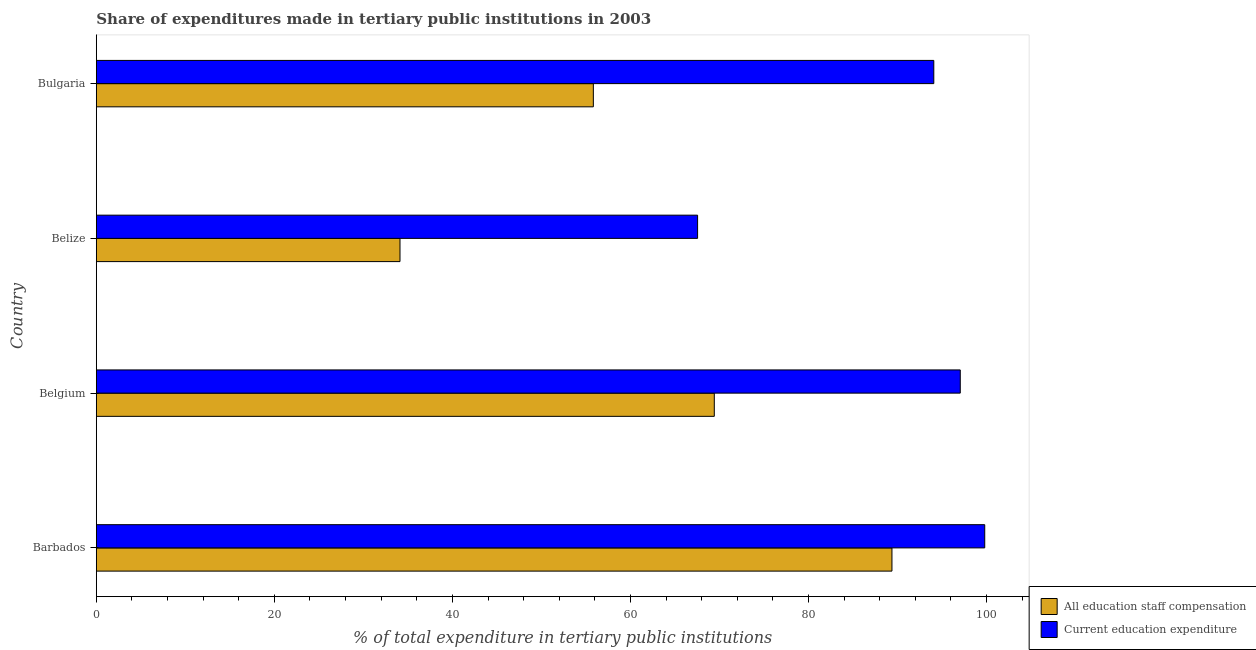How many different coloured bars are there?
Your answer should be compact. 2. How many groups of bars are there?
Make the answer very short. 4. How many bars are there on the 4th tick from the bottom?
Ensure brevity in your answer.  2. What is the label of the 1st group of bars from the top?
Offer a very short reply. Bulgaria. In how many cases, is the number of bars for a given country not equal to the number of legend labels?
Offer a very short reply. 0. What is the expenditure in education in Bulgaria?
Offer a terse response. 94.08. Across all countries, what is the maximum expenditure in staff compensation?
Provide a short and direct response. 89.38. Across all countries, what is the minimum expenditure in staff compensation?
Offer a very short reply. 34.11. In which country was the expenditure in staff compensation maximum?
Provide a succinct answer. Barbados. In which country was the expenditure in education minimum?
Offer a terse response. Belize. What is the total expenditure in staff compensation in the graph?
Provide a short and direct response. 248.76. What is the difference between the expenditure in education in Barbados and that in Bulgaria?
Your response must be concise. 5.72. What is the difference between the expenditure in education in Belgium and the expenditure in staff compensation in Barbados?
Offer a very short reply. 7.67. What is the average expenditure in staff compensation per country?
Ensure brevity in your answer.  62.19. What is the difference between the expenditure in staff compensation and expenditure in education in Barbados?
Provide a succinct answer. -10.42. What is the ratio of the expenditure in education in Barbados to that in Bulgaria?
Make the answer very short. 1.06. Is the difference between the expenditure in staff compensation in Belize and Bulgaria greater than the difference between the expenditure in education in Belize and Bulgaria?
Your response must be concise. Yes. What is the difference between the highest and the second highest expenditure in staff compensation?
Your answer should be compact. 19.96. What is the difference between the highest and the lowest expenditure in staff compensation?
Your response must be concise. 55.27. In how many countries, is the expenditure in education greater than the average expenditure in education taken over all countries?
Provide a short and direct response. 3. What does the 1st bar from the top in Belgium represents?
Your response must be concise. Current education expenditure. What does the 1st bar from the bottom in Belize represents?
Ensure brevity in your answer.  All education staff compensation. How are the legend labels stacked?
Make the answer very short. Vertical. What is the title of the graph?
Make the answer very short. Share of expenditures made in tertiary public institutions in 2003. What is the label or title of the X-axis?
Ensure brevity in your answer.  % of total expenditure in tertiary public institutions. What is the % of total expenditure in tertiary public institutions in All education staff compensation in Barbados?
Make the answer very short. 89.38. What is the % of total expenditure in tertiary public institutions of Current education expenditure in Barbados?
Give a very brief answer. 99.81. What is the % of total expenditure in tertiary public institutions in All education staff compensation in Belgium?
Your answer should be very brief. 69.43. What is the % of total expenditure in tertiary public institutions in Current education expenditure in Belgium?
Make the answer very short. 97.06. What is the % of total expenditure in tertiary public institutions in All education staff compensation in Belize?
Your answer should be compact. 34.11. What is the % of total expenditure in tertiary public institutions of Current education expenditure in Belize?
Your answer should be compact. 67.55. What is the % of total expenditure in tertiary public institutions in All education staff compensation in Bulgaria?
Keep it short and to the point. 55.84. What is the % of total expenditure in tertiary public institutions of Current education expenditure in Bulgaria?
Give a very brief answer. 94.08. Across all countries, what is the maximum % of total expenditure in tertiary public institutions of All education staff compensation?
Make the answer very short. 89.38. Across all countries, what is the maximum % of total expenditure in tertiary public institutions of Current education expenditure?
Ensure brevity in your answer.  99.81. Across all countries, what is the minimum % of total expenditure in tertiary public institutions of All education staff compensation?
Provide a short and direct response. 34.11. Across all countries, what is the minimum % of total expenditure in tertiary public institutions of Current education expenditure?
Provide a succinct answer. 67.55. What is the total % of total expenditure in tertiary public institutions in All education staff compensation in the graph?
Provide a succinct answer. 248.76. What is the total % of total expenditure in tertiary public institutions of Current education expenditure in the graph?
Provide a short and direct response. 358.5. What is the difference between the % of total expenditure in tertiary public institutions of All education staff compensation in Barbados and that in Belgium?
Keep it short and to the point. 19.96. What is the difference between the % of total expenditure in tertiary public institutions in Current education expenditure in Barbados and that in Belgium?
Ensure brevity in your answer.  2.75. What is the difference between the % of total expenditure in tertiary public institutions of All education staff compensation in Barbados and that in Belize?
Give a very brief answer. 55.27. What is the difference between the % of total expenditure in tertiary public institutions in Current education expenditure in Barbados and that in Belize?
Your response must be concise. 32.26. What is the difference between the % of total expenditure in tertiary public institutions in All education staff compensation in Barbados and that in Bulgaria?
Offer a very short reply. 33.55. What is the difference between the % of total expenditure in tertiary public institutions in Current education expenditure in Barbados and that in Bulgaria?
Make the answer very short. 5.72. What is the difference between the % of total expenditure in tertiary public institutions of All education staff compensation in Belgium and that in Belize?
Give a very brief answer. 35.31. What is the difference between the % of total expenditure in tertiary public institutions in Current education expenditure in Belgium and that in Belize?
Provide a succinct answer. 29.51. What is the difference between the % of total expenditure in tertiary public institutions of All education staff compensation in Belgium and that in Bulgaria?
Keep it short and to the point. 13.59. What is the difference between the % of total expenditure in tertiary public institutions in Current education expenditure in Belgium and that in Bulgaria?
Offer a terse response. 2.97. What is the difference between the % of total expenditure in tertiary public institutions in All education staff compensation in Belize and that in Bulgaria?
Provide a short and direct response. -21.72. What is the difference between the % of total expenditure in tertiary public institutions of Current education expenditure in Belize and that in Bulgaria?
Your response must be concise. -26.54. What is the difference between the % of total expenditure in tertiary public institutions of All education staff compensation in Barbados and the % of total expenditure in tertiary public institutions of Current education expenditure in Belgium?
Give a very brief answer. -7.67. What is the difference between the % of total expenditure in tertiary public institutions in All education staff compensation in Barbados and the % of total expenditure in tertiary public institutions in Current education expenditure in Belize?
Provide a succinct answer. 21.84. What is the difference between the % of total expenditure in tertiary public institutions in All education staff compensation in Barbados and the % of total expenditure in tertiary public institutions in Current education expenditure in Bulgaria?
Your answer should be compact. -4.7. What is the difference between the % of total expenditure in tertiary public institutions in All education staff compensation in Belgium and the % of total expenditure in tertiary public institutions in Current education expenditure in Belize?
Provide a succinct answer. 1.88. What is the difference between the % of total expenditure in tertiary public institutions of All education staff compensation in Belgium and the % of total expenditure in tertiary public institutions of Current education expenditure in Bulgaria?
Your answer should be compact. -24.66. What is the difference between the % of total expenditure in tertiary public institutions in All education staff compensation in Belize and the % of total expenditure in tertiary public institutions in Current education expenditure in Bulgaria?
Provide a succinct answer. -59.97. What is the average % of total expenditure in tertiary public institutions of All education staff compensation per country?
Your response must be concise. 62.19. What is the average % of total expenditure in tertiary public institutions in Current education expenditure per country?
Give a very brief answer. 89.62. What is the difference between the % of total expenditure in tertiary public institutions of All education staff compensation and % of total expenditure in tertiary public institutions of Current education expenditure in Barbados?
Your answer should be compact. -10.42. What is the difference between the % of total expenditure in tertiary public institutions of All education staff compensation and % of total expenditure in tertiary public institutions of Current education expenditure in Belgium?
Your answer should be compact. -27.63. What is the difference between the % of total expenditure in tertiary public institutions in All education staff compensation and % of total expenditure in tertiary public institutions in Current education expenditure in Belize?
Your answer should be compact. -33.43. What is the difference between the % of total expenditure in tertiary public institutions in All education staff compensation and % of total expenditure in tertiary public institutions in Current education expenditure in Bulgaria?
Keep it short and to the point. -38.25. What is the ratio of the % of total expenditure in tertiary public institutions of All education staff compensation in Barbados to that in Belgium?
Offer a terse response. 1.29. What is the ratio of the % of total expenditure in tertiary public institutions in Current education expenditure in Barbados to that in Belgium?
Your response must be concise. 1.03. What is the ratio of the % of total expenditure in tertiary public institutions in All education staff compensation in Barbados to that in Belize?
Your response must be concise. 2.62. What is the ratio of the % of total expenditure in tertiary public institutions in Current education expenditure in Barbados to that in Belize?
Ensure brevity in your answer.  1.48. What is the ratio of the % of total expenditure in tertiary public institutions in All education staff compensation in Barbados to that in Bulgaria?
Your response must be concise. 1.6. What is the ratio of the % of total expenditure in tertiary public institutions of Current education expenditure in Barbados to that in Bulgaria?
Your answer should be compact. 1.06. What is the ratio of the % of total expenditure in tertiary public institutions in All education staff compensation in Belgium to that in Belize?
Make the answer very short. 2.04. What is the ratio of the % of total expenditure in tertiary public institutions of Current education expenditure in Belgium to that in Belize?
Give a very brief answer. 1.44. What is the ratio of the % of total expenditure in tertiary public institutions of All education staff compensation in Belgium to that in Bulgaria?
Keep it short and to the point. 1.24. What is the ratio of the % of total expenditure in tertiary public institutions in Current education expenditure in Belgium to that in Bulgaria?
Your answer should be compact. 1.03. What is the ratio of the % of total expenditure in tertiary public institutions in All education staff compensation in Belize to that in Bulgaria?
Offer a very short reply. 0.61. What is the ratio of the % of total expenditure in tertiary public institutions of Current education expenditure in Belize to that in Bulgaria?
Your answer should be very brief. 0.72. What is the difference between the highest and the second highest % of total expenditure in tertiary public institutions in All education staff compensation?
Your response must be concise. 19.96. What is the difference between the highest and the second highest % of total expenditure in tertiary public institutions of Current education expenditure?
Keep it short and to the point. 2.75. What is the difference between the highest and the lowest % of total expenditure in tertiary public institutions of All education staff compensation?
Offer a very short reply. 55.27. What is the difference between the highest and the lowest % of total expenditure in tertiary public institutions in Current education expenditure?
Provide a succinct answer. 32.26. 